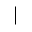Convert formula to latex. <formula><loc_0><loc_0><loc_500><loc_500>|</formula> 